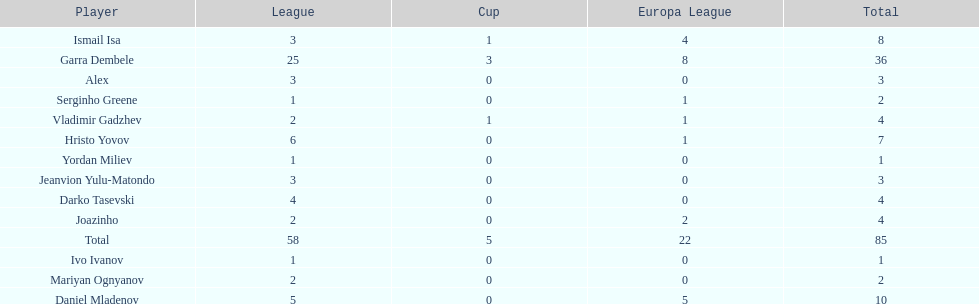Which player is in the same league as joazinho and vladimir gadzhev? Mariyan Ognyanov. 